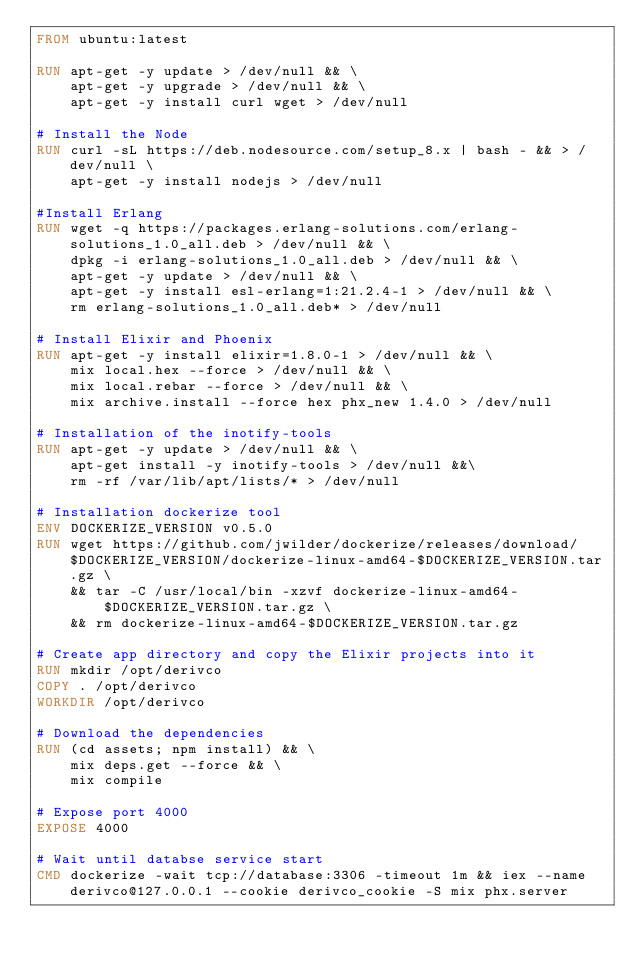<code> <loc_0><loc_0><loc_500><loc_500><_Dockerfile_>FROM ubuntu:latest

RUN apt-get -y update > /dev/null && \
    apt-get -y upgrade > /dev/null && \
    apt-get -y install curl wget > /dev/null 

# Install the Node
RUN curl -sL https://deb.nodesource.com/setup_8.x | bash - && > /dev/null \
    apt-get -y install nodejs > /dev/null 

#Install Erlang
RUN wget -q https://packages.erlang-solutions.com/erlang-solutions_1.0_all.deb > /dev/null && \
    dpkg -i erlang-solutions_1.0_all.deb > /dev/null && \
    apt-get -y update > /dev/null && \
    apt-get -y install esl-erlang=1:21.2.4-1 > /dev/null && \
    rm erlang-solutions_1.0_all.deb* > /dev/null 

# Install Elixir and Phoenix
RUN apt-get -y install elixir=1.8.0-1 > /dev/null && \
    mix local.hex --force > /dev/null && \
    mix local.rebar --force > /dev/null && \
    mix archive.install --force hex phx_new 1.4.0 > /dev/null 

# Installation of the inotify-tools
RUN apt-get -y update > /dev/null && \
    apt-get install -y inotify-tools > /dev/null &&\
    rm -rf /var/lib/apt/lists/* > /dev/null

# Installation dockerize tool
ENV DOCKERIZE_VERSION v0.5.0
RUN wget https://github.com/jwilder/dockerize/releases/download/$DOCKERIZE_VERSION/dockerize-linux-amd64-$DOCKERIZE_VERSION.tar.gz \
    && tar -C /usr/local/bin -xzvf dockerize-linux-amd64-$DOCKERIZE_VERSION.tar.gz \
    && rm dockerize-linux-amd64-$DOCKERIZE_VERSION.tar.gz

# Create app directory and copy the Elixir projects into it
RUN mkdir /opt/derivco
COPY . /opt/derivco
WORKDIR /opt/derivco

# Download the dependencies
RUN (cd assets; npm install) && \
    mix deps.get --force && \
    mix compile

# Expose port 4000
EXPOSE 4000

# Wait until databse service start
CMD dockerize -wait tcp://database:3306 -timeout 1m && iex --name derivco@127.0.0.1 --cookie derivco_cookie -S mix phx.server</code> 